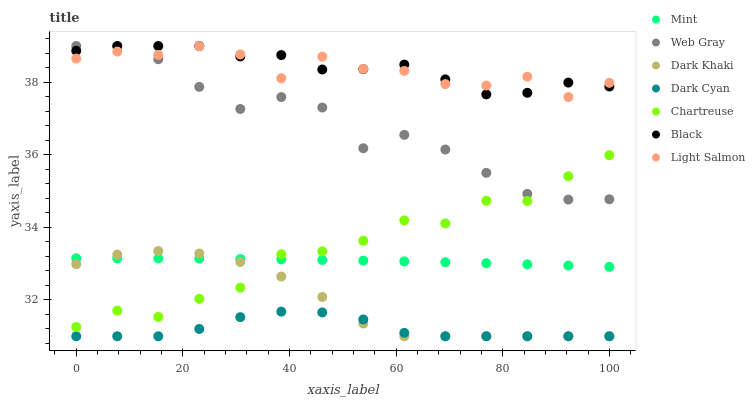Does Dark Cyan have the minimum area under the curve?
Answer yes or no. Yes. Does Black have the maximum area under the curve?
Answer yes or no. Yes. Does Web Gray have the minimum area under the curve?
Answer yes or no. No. Does Web Gray have the maximum area under the curve?
Answer yes or no. No. Is Mint the smoothest?
Answer yes or no. Yes. Is Light Salmon the roughest?
Answer yes or no. Yes. Is Web Gray the smoothest?
Answer yes or no. No. Is Web Gray the roughest?
Answer yes or no. No. Does Dark Khaki have the lowest value?
Answer yes or no. Yes. Does Web Gray have the lowest value?
Answer yes or no. No. Does Black have the highest value?
Answer yes or no. Yes. Does Dark Khaki have the highest value?
Answer yes or no. No. Is Dark Cyan less than Black?
Answer yes or no. Yes. Is Web Gray greater than Mint?
Answer yes or no. Yes. Does Mint intersect Dark Khaki?
Answer yes or no. Yes. Is Mint less than Dark Khaki?
Answer yes or no. No. Is Mint greater than Dark Khaki?
Answer yes or no. No. Does Dark Cyan intersect Black?
Answer yes or no. No. 